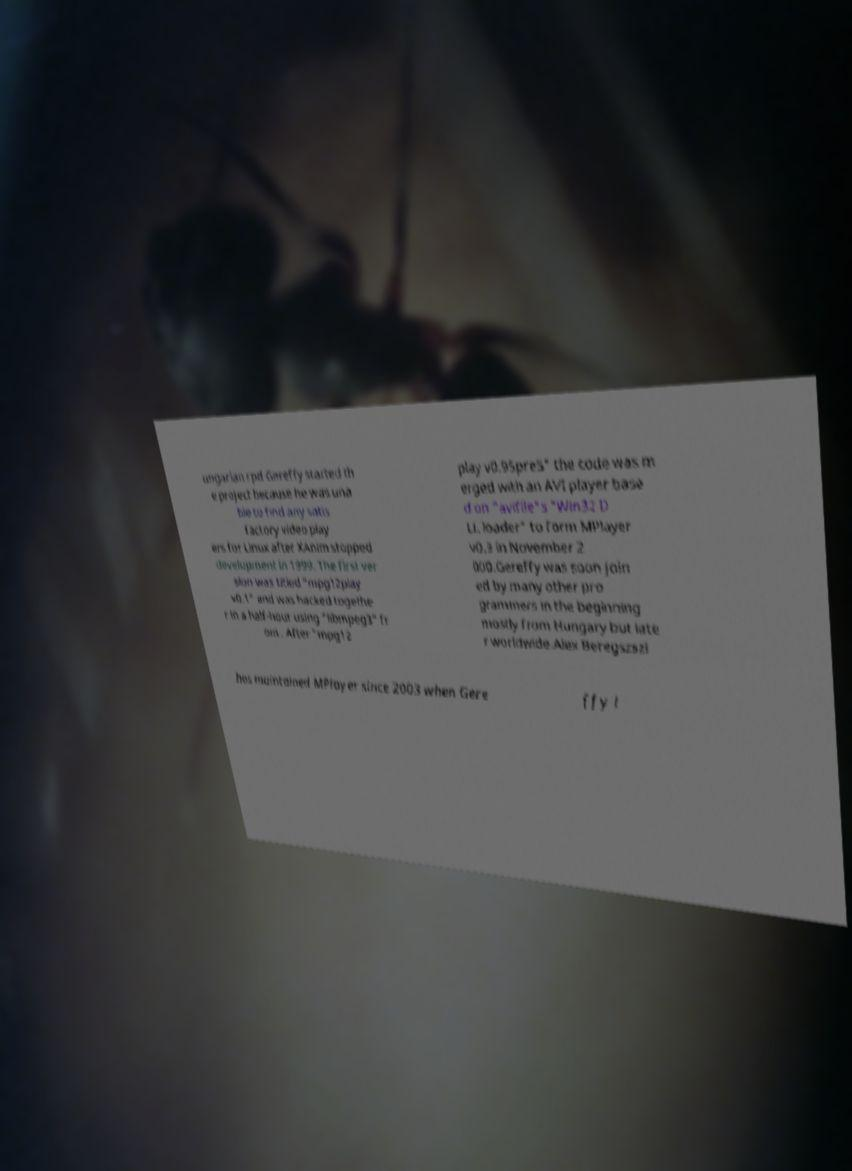Could you assist in decoding the text presented in this image and type it out clearly? ungarian rpd Gereffy started th e project because he was una ble to find any satis factory video play ers for Linux after XAnim stopped development in 1999. The first ver sion was titled "mpg12play v0.1" and was hacked togethe r in a half-hour using "libmpeg3" fr om . After "mpg12 play v0.95pre5" the code was m erged with an AVI player base d on "avifile"s "Win32 D LL loader" to form MPlayer v0.3 in November 2 000.Gereffy was soon join ed by many other pro grammers in the beginning mostly from Hungary but late r worldwide.Alex Beregszszi has maintained MPlayer since 2003 when Gere ffy l 